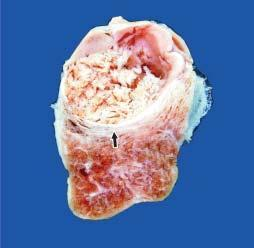what does cut surface of the enlarged thyroid gland show?
Answer the question using a single word or phrase. A single nodule separated from the rest of thyroid parenchyma by incomplete fibrous septa 